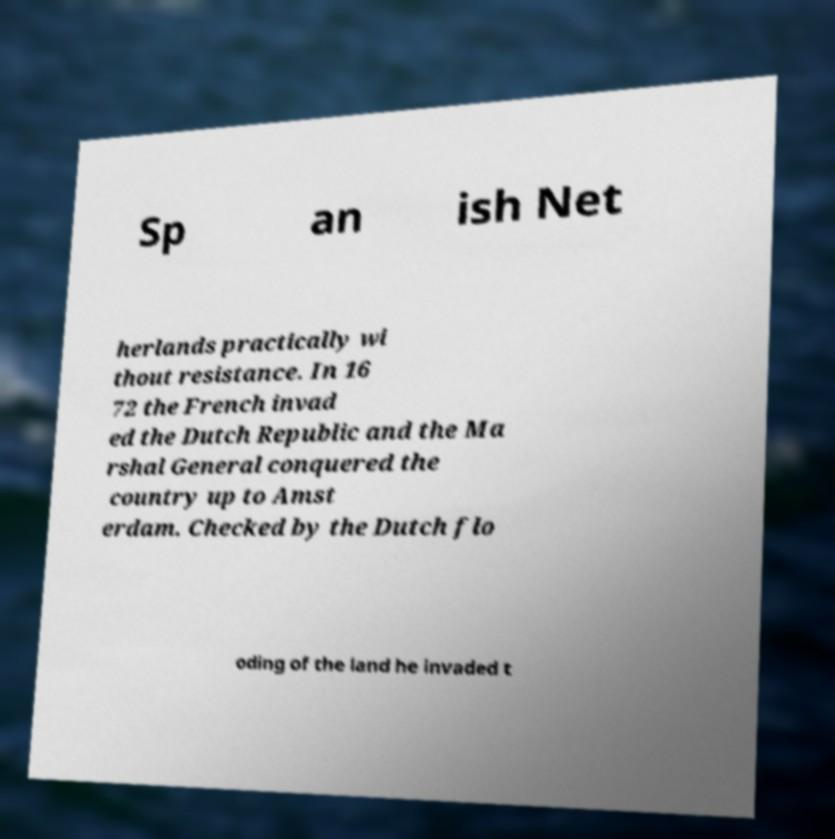There's text embedded in this image that I need extracted. Can you transcribe it verbatim? Sp an ish Net herlands practically wi thout resistance. In 16 72 the French invad ed the Dutch Republic and the Ma rshal General conquered the country up to Amst erdam. Checked by the Dutch flo oding of the land he invaded t 